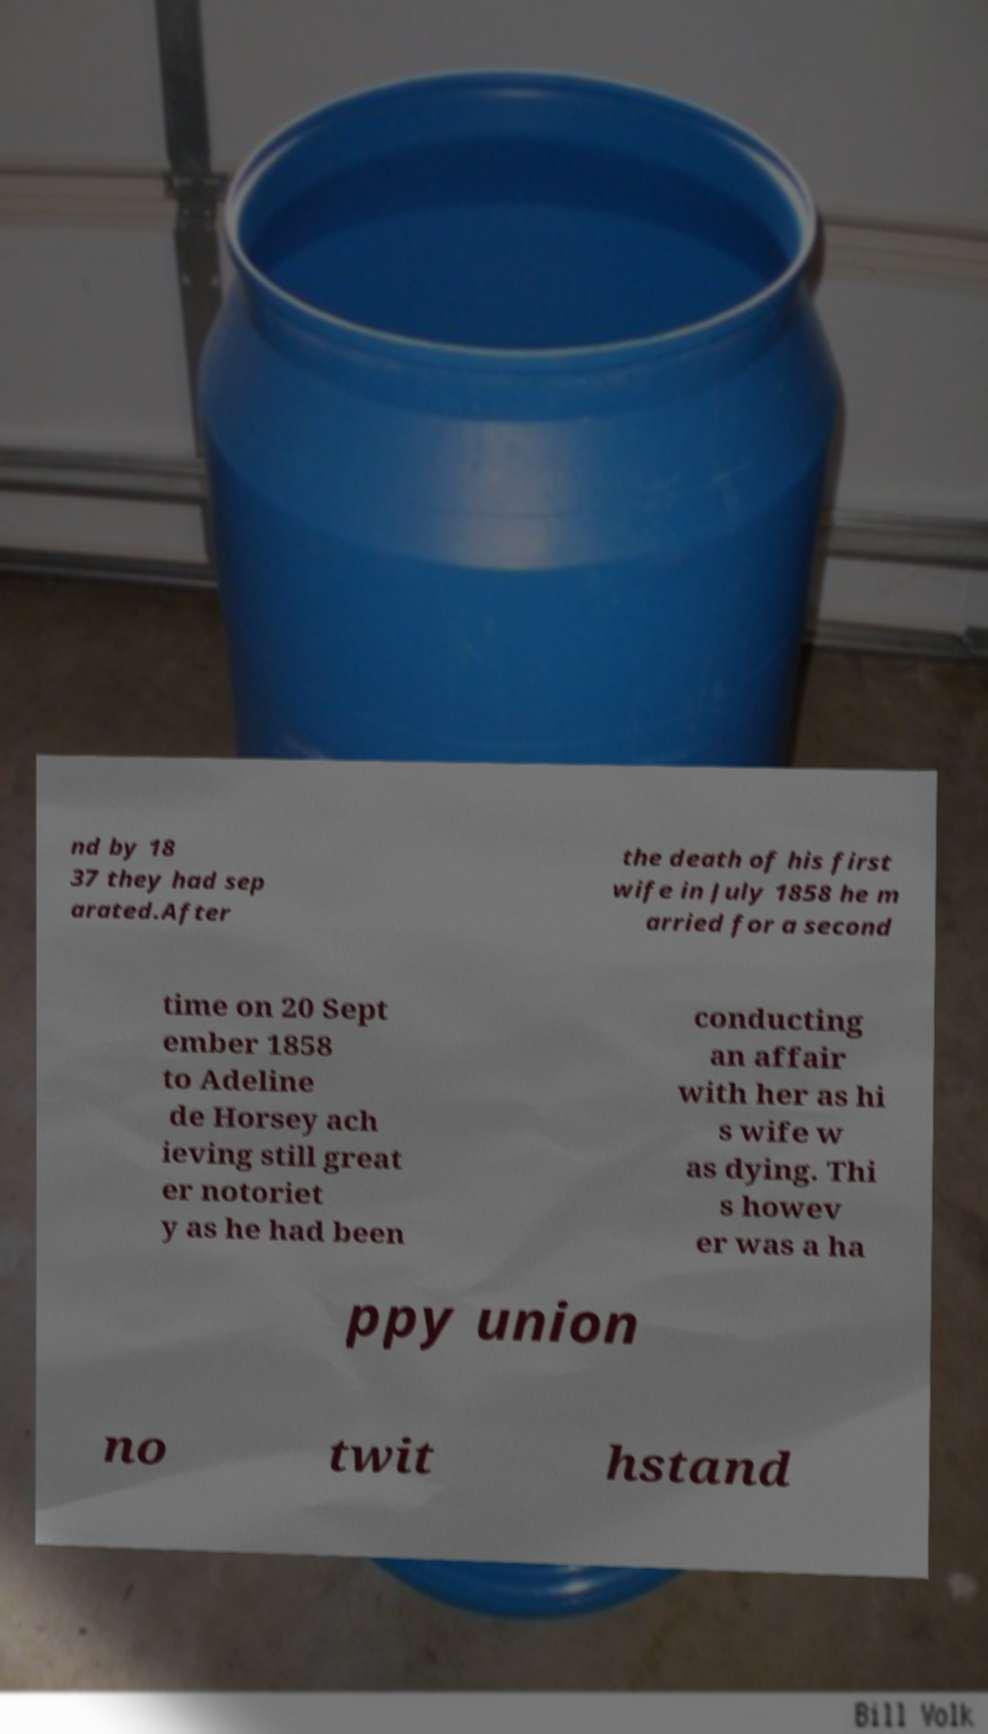Please read and relay the text visible in this image. What does it say? nd by 18 37 they had sep arated.After the death of his first wife in July 1858 he m arried for a second time on 20 Sept ember 1858 to Adeline de Horsey ach ieving still great er notoriet y as he had been conducting an affair with her as hi s wife w as dying. Thi s howev er was a ha ppy union no twit hstand 